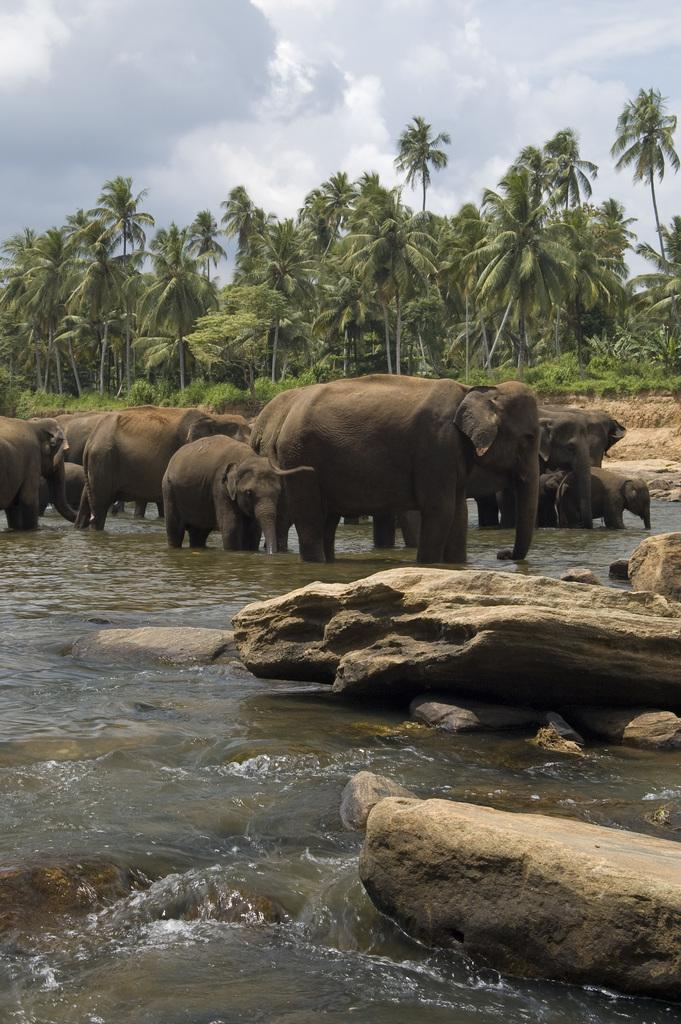What is the primary element visible in the image? There is water in the image. What other objects or features can be seen in the image? There are rocks, elephants, and trees in the image. What is visible at the top of the image? The sky is visible at the top of the image. What type of weather can be seen in the image? There is no indication of weather in the image; it only shows water, rocks, elephants, trees, and the sky. What class of animals is present in the image? The image does not depict a class of animals; it shows elephants, which are a specific type of animal. 